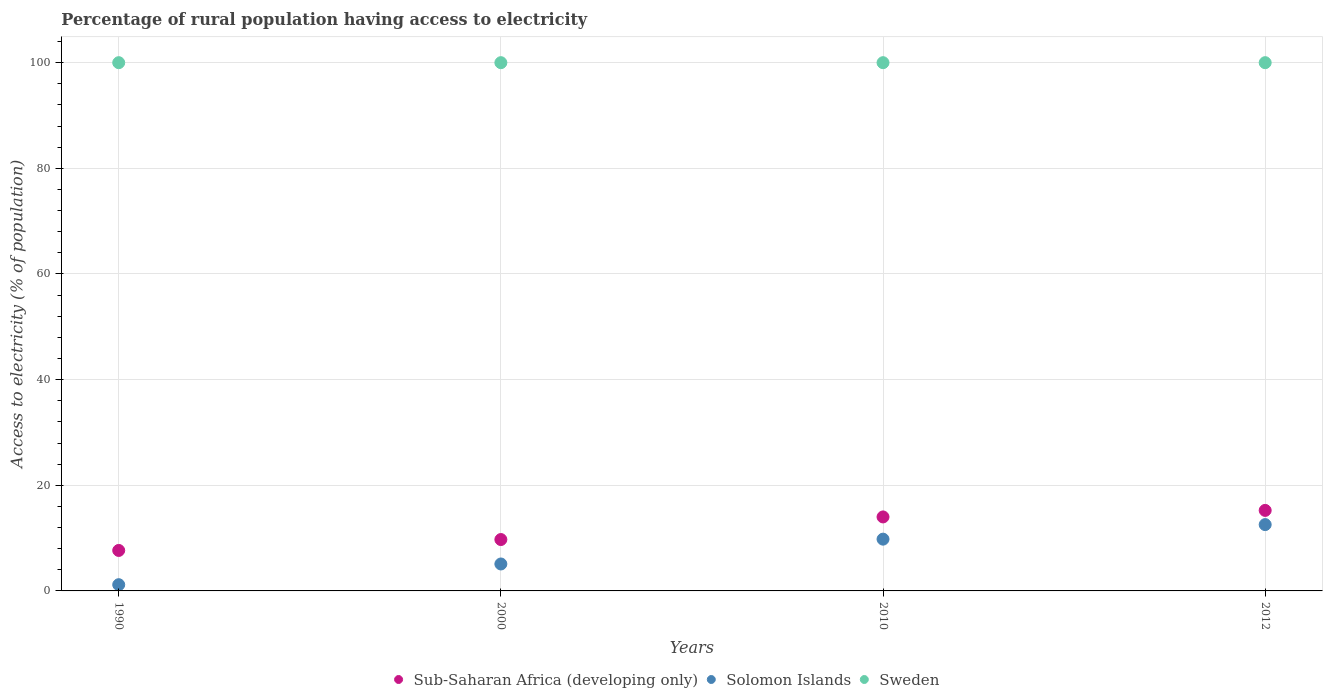How many different coloured dotlines are there?
Make the answer very short. 3. Is the number of dotlines equal to the number of legend labels?
Your response must be concise. Yes. What is the percentage of rural population having access to electricity in Solomon Islands in 2000?
Offer a very short reply. 5.1. Across all years, what is the maximum percentage of rural population having access to electricity in Solomon Islands?
Make the answer very short. 12.55. Across all years, what is the minimum percentage of rural population having access to electricity in Sub-Saharan Africa (developing only)?
Your answer should be compact. 7.66. In which year was the percentage of rural population having access to electricity in Solomon Islands maximum?
Offer a very short reply. 2012. What is the total percentage of rural population having access to electricity in Sweden in the graph?
Provide a short and direct response. 400. What is the difference between the percentage of rural population having access to electricity in Sub-Saharan Africa (developing only) in 1990 and that in 2000?
Your answer should be compact. -2.06. What is the difference between the percentage of rural population having access to electricity in Solomon Islands in 1990 and the percentage of rural population having access to electricity in Sub-Saharan Africa (developing only) in 2000?
Your response must be concise. -8.55. In the year 2012, what is the difference between the percentage of rural population having access to electricity in Solomon Islands and percentage of rural population having access to electricity in Sub-Saharan Africa (developing only)?
Keep it short and to the point. -2.69. What is the ratio of the percentage of rural population having access to electricity in Sweden in 1990 to that in 2010?
Your answer should be very brief. 1. What is the difference between the highest and the lowest percentage of rural population having access to electricity in Sub-Saharan Africa (developing only)?
Ensure brevity in your answer.  7.58. In how many years, is the percentage of rural population having access to electricity in Sweden greater than the average percentage of rural population having access to electricity in Sweden taken over all years?
Your response must be concise. 0. Is it the case that in every year, the sum of the percentage of rural population having access to electricity in Solomon Islands and percentage of rural population having access to electricity in Sub-Saharan Africa (developing only)  is greater than the percentage of rural population having access to electricity in Sweden?
Your answer should be compact. No. How many dotlines are there?
Offer a terse response. 3. How many years are there in the graph?
Provide a succinct answer. 4. Does the graph contain grids?
Keep it short and to the point. Yes. How are the legend labels stacked?
Give a very brief answer. Horizontal. What is the title of the graph?
Offer a very short reply. Percentage of rural population having access to electricity. Does "Faeroe Islands" appear as one of the legend labels in the graph?
Give a very brief answer. No. What is the label or title of the X-axis?
Make the answer very short. Years. What is the label or title of the Y-axis?
Provide a short and direct response. Access to electricity (% of population). What is the Access to electricity (% of population) in Sub-Saharan Africa (developing only) in 1990?
Your answer should be compact. 7.66. What is the Access to electricity (% of population) in Solomon Islands in 1990?
Provide a short and direct response. 1.18. What is the Access to electricity (% of population) of Sweden in 1990?
Provide a short and direct response. 100. What is the Access to electricity (% of population) in Sub-Saharan Africa (developing only) in 2000?
Give a very brief answer. 9.73. What is the Access to electricity (% of population) in Solomon Islands in 2000?
Provide a succinct answer. 5.1. What is the Access to electricity (% of population) in Sweden in 2000?
Ensure brevity in your answer.  100. What is the Access to electricity (% of population) in Sub-Saharan Africa (developing only) in 2010?
Provide a succinct answer. 14.01. What is the Access to electricity (% of population) of Sweden in 2010?
Your answer should be compact. 100. What is the Access to electricity (% of population) of Sub-Saharan Africa (developing only) in 2012?
Ensure brevity in your answer.  15.24. What is the Access to electricity (% of population) in Solomon Islands in 2012?
Keep it short and to the point. 12.55. What is the Access to electricity (% of population) in Sweden in 2012?
Provide a short and direct response. 100. Across all years, what is the maximum Access to electricity (% of population) of Sub-Saharan Africa (developing only)?
Your response must be concise. 15.24. Across all years, what is the maximum Access to electricity (% of population) in Solomon Islands?
Offer a terse response. 12.55. Across all years, what is the maximum Access to electricity (% of population) of Sweden?
Provide a succinct answer. 100. Across all years, what is the minimum Access to electricity (% of population) in Sub-Saharan Africa (developing only)?
Give a very brief answer. 7.66. Across all years, what is the minimum Access to electricity (% of population) in Solomon Islands?
Provide a short and direct response. 1.18. Across all years, what is the minimum Access to electricity (% of population) of Sweden?
Provide a short and direct response. 100. What is the total Access to electricity (% of population) in Sub-Saharan Africa (developing only) in the graph?
Make the answer very short. 46.64. What is the total Access to electricity (% of population) in Solomon Islands in the graph?
Your response must be concise. 28.63. What is the total Access to electricity (% of population) in Sweden in the graph?
Offer a very short reply. 400. What is the difference between the Access to electricity (% of population) in Sub-Saharan Africa (developing only) in 1990 and that in 2000?
Offer a terse response. -2.06. What is the difference between the Access to electricity (% of population) in Solomon Islands in 1990 and that in 2000?
Offer a very short reply. -3.92. What is the difference between the Access to electricity (% of population) of Sub-Saharan Africa (developing only) in 1990 and that in 2010?
Keep it short and to the point. -6.34. What is the difference between the Access to electricity (% of population) in Solomon Islands in 1990 and that in 2010?
Your answer should be compact. -8.62. What is the difference between the Access to electricity (% of population) of Sub-Saharan Africa (developing only) in 1990 and that in 2012?
Your answer should be compact. -7.58. What is the difference between the Access to electricity (% of population) of Solomon Islands in 1990 and that in 2012?
Your response must be concise. -11.38. What is the difference between the Access to electricity (% of population) of Sub-Saharan Africa (developing only) in 2000 and that in 2010?
Provide a succinct answer. -4.28. What is the difference between the Access to electricity (% of population) of Sweden in 2000 and that in 2010?
Offer a very short reply. 0. What is the difference between the Access to electricity (% of population) of Sub-Saharan Africa (developing only) in 2000 and that in 2012?
Keep it short and to the point. -5.52. What is the difference between the Access to electricity (% of population) of Solomon Islands in 2000 and that in 2012?
Keep it short and to the point. -7.45. What is the difference between the Access to electricity (% of population) of Sub-Saharan Africa (developing only) in 2010 and that in 2012?
Provide a short and direct response. -1.24. What is the difference between the Access to electricity (% of population) of Solomon Islands in 2010 and that in 2012?
Ensure brevity in your answer.  -2.75. What is the difference between the Access to electricity (% of population) of Sub-Saharan Africa (developing only) in 1990 and the Access to electricity (% of population) of Solomon Islands in 2000?
Your response must be concise. 2.56. What is the difference between the Access to electricity (% of population) in Sub-Saharan Africa (developing only) in 1990 and the Access to electricity (% of population) in Sweden in 2000?
Your answer should be very brief. -92.34. What is the difference between the Access to electricity (% of population) in Solomon Islands in 1990 and the Access to electricity (% of population) in Sweden in 2000?
Provide a short and direct response. -98.82. What is the difference between the Access to electricity (% of population) of Sub-Saharan Africa (developing only) in 1990 and the Access to electricity (% of population) of Solomon Islands in 2010?
Offer a terse response. -2.14. What is the difference between the Access to electricity (% of population) of Sub-Saharan Africa (developing only) in 1990 and the Access to electricity (% of population) of Sweden in 2010?
Keep it short and to the point. -92.34. What is the difference between the Access to electricity (% of population) of Solomon Islands in 1990 and the Access to electricity (% of population) of Sweden in 2010?
Give a very brief answer. -98.82. What is the difference between the Access to electricity (% of population) of Sub-Saharan Africa (developing only) in 1990 and the Access to electricity (% of population) of Solomon Islands in 2012?
Your response must be concise. -4.89. What is the difference between the Access to electricity (% of population) of Sub-Saharan Africa (developing only) in 1990 and the Access to electricity (% of population) of Sweden in 2012?
Your response must be concise. -92.34. What is the difference between the Access to electricity (% of population) in Solomon Islands in 1990 and the Access to electricity (% of population) in Sweden in 2012?
Your response must be concise. -98.82. What is the difference between the Access to electricity (% of population) of Sub-Saharan Africa (developing only) in 2000 and the Access to electricity (% of population) of Solomon Islands in 2010?
Ensure brevity in your answer.  -0.07. What is the difference between the Access to electricity (% of population) of Sub-Saharan Africa (developing only) in 2000 and the Access to electricity (% of population) of Sweden in 2010?
Your answer should be compact. -90.27. What is the difference between the Access to electricity (% of population) of Solomon Islands in 2000 and the Access to electricity (% of population) of Sweden in 2010?
Make the answer very short. -94.9. What is the difference between the Access to electricity (% of population) in Sub-Saharan Africa (developing only) in 2000 and the Access to electricity (% of population) in Solomon Islands in 2012?
Provide a succinct answer. -2.83. What is the difference between the Access to electricity (% of population) of Sub-Saharan Africa (developing only) in 2000 and the Access to electricity (% of population) of Sweden in 2012?
Your response must be concise. -90.27. What is the difference between the Access to electricity (% of population) in Solomon Islands in 2000 and the Access to electricity (% of population) in Sweden in 2012?
Make the answer very short. -94.9. What is the difference between the Access to electricity (% of population) of Sub-Saharan Africa (developing only) in 2010 and the Access to electricity (% of population) of Solomon Islands in 2012?
Make the answer very short. 1.45. What is the difference between the Access to electricity (% of population) of Sub-Saharan Africa (developing only) in 2010 and the Access to electricity (% of population) of Sweden in 2012?
Offer a very short reply. -85.99. What is the difference between the Access to electricity (% of population) of Solomon Islands in 2010 and the Access to electricity (% of population) of Sweden in 2012?
Give a very brief answer. -90.2. What is the average Access to electricity (% of population) of Sub-Saharan Africa (developing only) per year?
Give a very brief answer. 11.66. What is the average Access to electricity (% of population) in Solomon Islands per year?
Offer a very short reply. 7.16. In the year 1990, what is the difference between the Access to electricity (% of population) of Sub-Saharan Africa (developing only) and Access to electricity (% of population) of Solomon Islands?
Offer a very short reply. 6.48. In the year 1990, what is the difference between the Access to electricity (% of population) in Sub-Saharan Africa (developing only) and Access to electricity (% of population) in Sweden?
Give a very brief answer. -92.34. In the year 1990, what is the difference between the Access to electricity (% of population) of Solomon Islands and Access to electricity (% of population) of Sweden?
Ensure brevity in your answer.  -98.82. In the year 2000, what is the difference between the Access to electricity (% of population) of Sub-Saharan Africa (developing only) and Access to electricity (% of population) of Solomon Islands?
Your response must be concise. 4.63. In the year 2000, what is the difference between the Access to electricity (% of population) in Sub-Saharan Africa (developing only) and Access to electricity (% of population) in Sweden?
Offer a terse response. -90.27. In the year 2000, what is the difference between the Access to electricity (% of population) in Solomon Islands and Access to electricity (% of population) in Sweden?
Offer a terse response. -94.9. In the year 2010, what is the difference between the Access to electricity (% of population) in Sub-Saharan Africa (developing only) and Access to electricity (% of population) in Solomon Islands?
Your response must be concise. 4.21. In the year 2010, what is the difference between the Access to electricity (% of population) of Sub-Saharan Africa (developing only) and Access to electricity (% of population) of Sweden?
Provide a succinct answer. -85.99. In the year 2010, what is the difference between the Access to electricity (% of population) of Solomon Islands and Access to electricity (% of population) of Sweden?
Ensure brevity in your answer.  -90.2. In the year 2012, what is the difference between the Access to electricity (% of population) in Sub-Saharan Africa (developing only) and Access to electricity (% of population) in Solomon Islands?
Make the answer very short. 2.69. In the year 2012, what is the difference between the Access to electricity (% of population) in Sub-Saharan Africa (developing only) and Access to electricity (% of population) in Sweden?
Your response must be concise. -84.76. In the year 2012, what is the difference between the Access to electricity (% of population) of Solomon Islands and Access to electricity (% of population) of Sweden?
Provide a succinct answer. -87.45. What is the ratio of the Access to electricity (% of population) of Sub-Saharan Africa (developing only) in 1990 to that in 2000?
Your answer should be very brief. 0.79. What is the ratio of the Access to electricity (% of population) of Solomon Islands in 1990 to that in 2000?
Give a very brief answer. 0.23. What is the ratio of the Access to electricity (% of population) in Sub-Saharan Africa (developing only) in 1990 to that in 2010?
Your answer should be very brief. 0.55. What is the ratio of the Access to electricity (% of population) in Solomon Islands in 1990 to that in 2010?
Provide a short and direct response. 0.12. What is the ratio of the Access to electricity (% of population) in Sub-Saharan Africa (developing only) in 1990 to that in 2012?
Ensure brevity in your answer.  0.5. What is the ratio of the Access to electricity (% of population) of Solomon Islands in 1990 to that in 2012?
Offer a very short reply. 0.09. What is the ratio of the Access to electricity (% of population) in Sub-Saharan Africa (developing only) in 2000 to that in 2010?
Your answer should be compact. 0.69. What is the ratio of the Access to electricity (% of population) in Solomon Islands in 2000 to that in 2010?
Ensure brevity in your answer.  0.52. What is the ratio of the Access to electricity (% of population) in Sweden in 2000 to that in 2010?
Your answer should be compact. 1. What is the ratio of the Access to electricity (% of population) of Sub-Saharan Africa (developing only) in 2000 to that in 2012?
Provide a succinct answer. 0.64. What is the ratio of the Access to electricity (% of population) in Solomon Islands in 2000 to that in 2012?
Offer a very short reply. 0.41. What is the ratio of the Access to electricity (% of population) of Sweden in 2000 to that in 2012?
Ensure brevity in your answer.  1. What is the ratio of the Access to electricity (% of population) of Sub-Saharan Africa (developing only) in 2010 to that in 2012?
Your response must be concise. 0.92. What is the ratio of the Access to electricity (% of population) in Solomon Islands in 2010 to that in 2012?
Make the answer very short. 0.78. What is the ratio of the Access to electricity (% of population) of Sweden in 2010 to that in 2012?
Ensure brevity in your answer.  1. What is the difference between the highest and the second highest Access to electricity (% of population) of Sub-Saharan Africa (developing only)?
Offer a terse response. 1.24. What is the difference between the highest and the second highest Access to electricity (% of population) in Solomon Islands?
Your answer should be very brief. 2.75. What is the difference between the highest and the lowest Access to electricity (% of population) in Sub-Saharan Africa (developing only)?
Offer a very short reply. 7.58. What is the difference between the highest and the lowest Access to electricity (% of population) of Solomon Islands?
Offer a very short reply. 11.38. What is the difference between the highest and the lowest Access to electricity (% of population) of Sweden?
Your answer should be very brief. 0. 